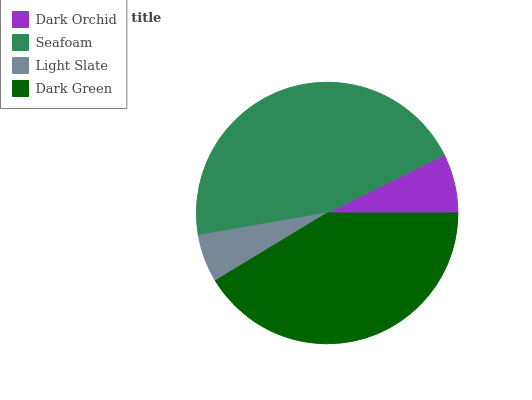Is Light Slate the minimum?
Answer yes or no. Yes. Is Seafoam the maximum?
Answer yes or no. Yes. Is Seafoam the minimum?
Answer yes or no. No. Is Light Slate the maximum?
Answer yes or no. No. Is Seafoam greater than Light Slate?
Answer yes or no. Yes. Is Light Slate less than Seafoam?
Answer yes or no. Yes. Is Light Slate greater than Seafoam?
Answer yes or no. No. Is Seafoam less than Light Slate?
Answer yes or no. No. Is Dark Green the high median?
Answer yes or no. Yes. Is Dark Orchid the low median?
Answer yes or no. Yes. Is Light Slate the high median?
Answer yes or no. No. Is Dark Green the low median?
Answer yes or no. No. 